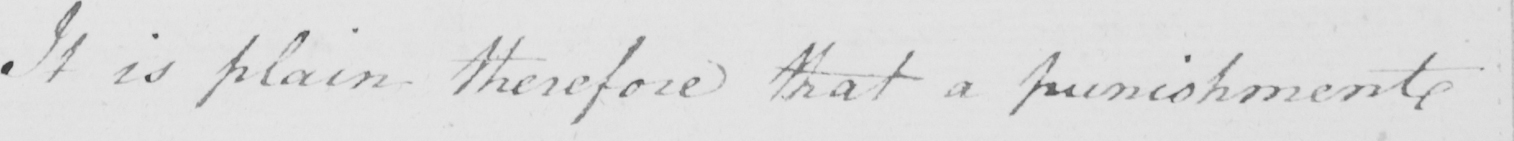What is written in this line of handwriting? It is plain therefore that a punishment 